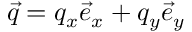Convert formula to latex. <formula><loc_0><loc_0><loc_500><loc_500>\vec { q } = q _ { x } \vec { e } _ { x } + q _ { y } \vec { e } _ { y }</formula> 